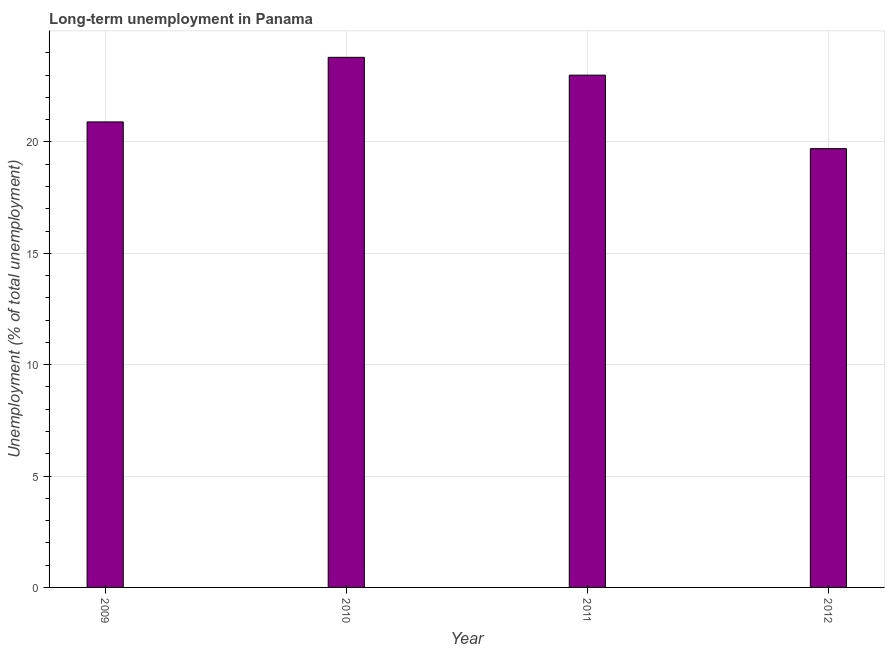What is the title of the graph?
Give a very brief answer. Long-term unemployment in Panama. What is the label or title of the X-axis?
Offer a very short reply. Year. What is the label or title of the Y-axis?
Make the answer very short. Unemployment (% of total unemployment). Across all years, what is the maximum long-term unemployment?
Offer a terse response. 23.8. Across all years, what is the minimum long-term unemployment?
Provide a short and direct response. 19.7. In which year was the long-term unemployment maximum?
Offer a very short reply. 2010. What is the sum of the long-term unemployment?
Provide a succinct answer. 87.4. What is the average long-term unemployment per year?
Offer a very short reply. 21.85. What is the median long-term unemployment?
Offer a terse response. 21.95. Do a majority of the years between 2011 and 2012 (inclusive) have long-term unemployment greater than 9 %?
Your answer should be compact. Yes. What is the ratio of the long-term unemployment in 2009 to that in 2012?
Offer a very short reply. 1.06. Is the difference between the long-term unemployment in 2009 and 2010 greater than the difference between any two years?
Make the answer very short. No. Is the sum of the long-term unemployment in 2010 and 2011 greater than the maximum long-term unemployment across all years?
Offer a terse response. Yes. What is the difference between the highest and the lowest long-term unemployment?
Your answer should be very brief. 4.1. In how many years, is the long-term unemployment greater than the average long-term unemployment taken over all years?
Your answer should be compact. 2. Are all the bars in the graph horizontal?
Your answer should be very brief. No. Are the values on the major ticks of Y-axis written in scientific E-notation?
Your answer should be compact. No. What is the Unemployment (% of total unemployment) of 2009?
Your answer should be very brief. 20.9. What is the Unemployment (% of total unemployment) in 2010?
Provide a succinct answer. 23.8. What is the Unemployment (% of total unemployment) of 2012?
Give a very brief answer. 19.7. What is the difference between the Unemployment (% of total unemployment) in 2009 and 2010?
Offer a very short reply. -2.9. What is the difference between the Unemployment (% of total unemployment) in 2009 and 2012?
Keep it short and to the point. 1.2. What is the difference between the Unemployment (% of total unemployment) in 2010 and 2011?
Make the answer very short. 0.8. What is the difference between the Unemployment (% of total unemployment) in 2011 and 2012?
Your response must be concise. 3.3. What is the ratio of the Unemployment (% of total unemployment) in 2009 to that in 2010?
Ensure brevity in your answer.  0.88. What is the ratio of the Unemployment (% of total unemployment) in 2009 to that in 2011?
Offer a very short reply. 0.91. What is the ratio of the Unemployment (% of total unemployment) in 2009 to that in 2012?
Offer a terse response. 1.06. What is the ratio of the Unemployment (% of total unemployment) in 2010 to that in 2011?
Offer a terse response. 1.03. What is the ratio of the Unemployment (% of total unemployment) in 2010 to that in 2012?
Ensure brevity in your answer.  1.21. What is the ratio of the Unemployment (% of total unemployment) in 2011 to that in 2012?
Offer a terse response. 1.17. 